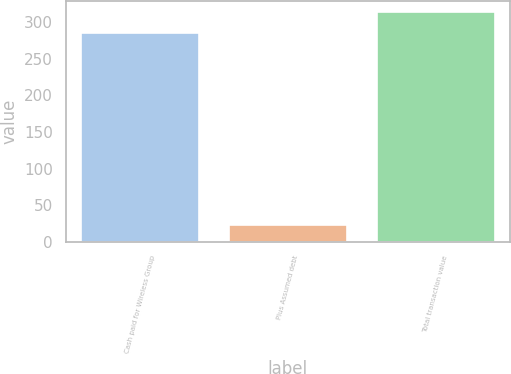<chart> <loc_0><loc_0><loc_500><loc_500><bar_chart><fcel>Cash paid for Wireless Group<fcel>Plus Assumed debt<fcel>Total transaction value<nl><fcel>285<fcel>23<fcel>313.5<nl></chart> 